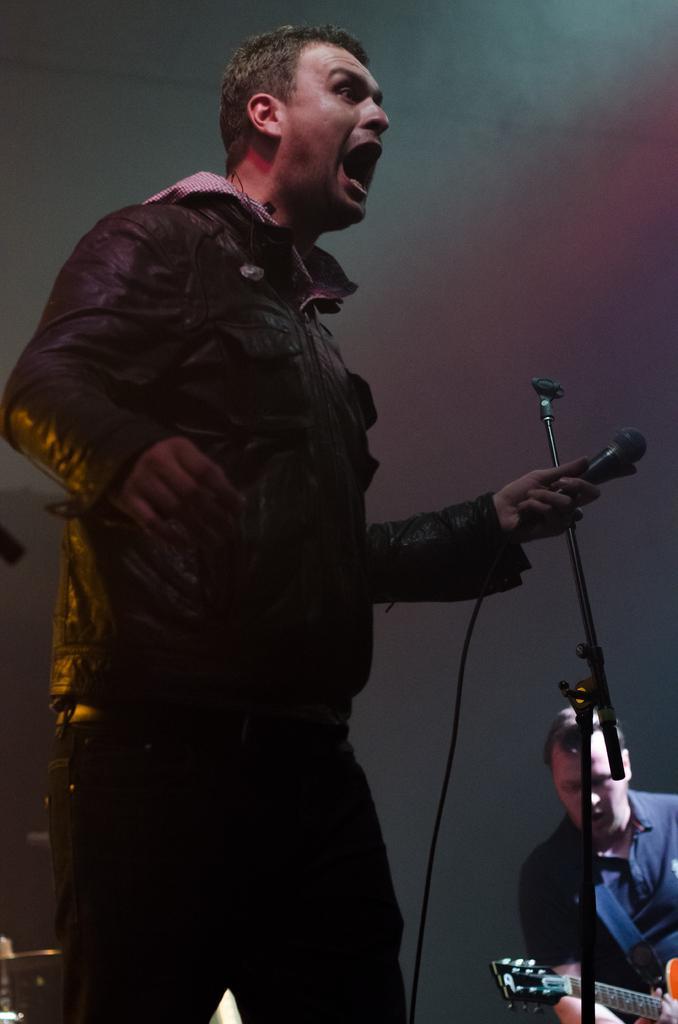In one or two sentences, can you explain what this image depicts? There is a man standing in the center. He is wearing a jacket and he holds a microphone in his left hand and he is shouting. There is another person on the right side and he is holding a guitar in his hand. 